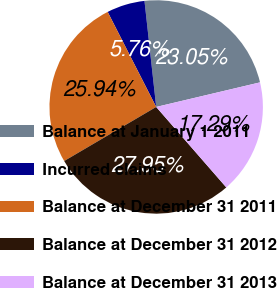<chart> <loc_0><loc_0><loc_500><loc_500><pie_chart><fcel>Balance at January 1 2011<fcel>Incurred claims<fcel>Balance at December 31 2011<fcel>Balance at December 31 2012<fcel>Balance at December 31 2013<nl><fcel>23.05%<fcel>5.76%<fcel>25.94%<fcel>27.95%<fcel>17.29%<nl></chart> 